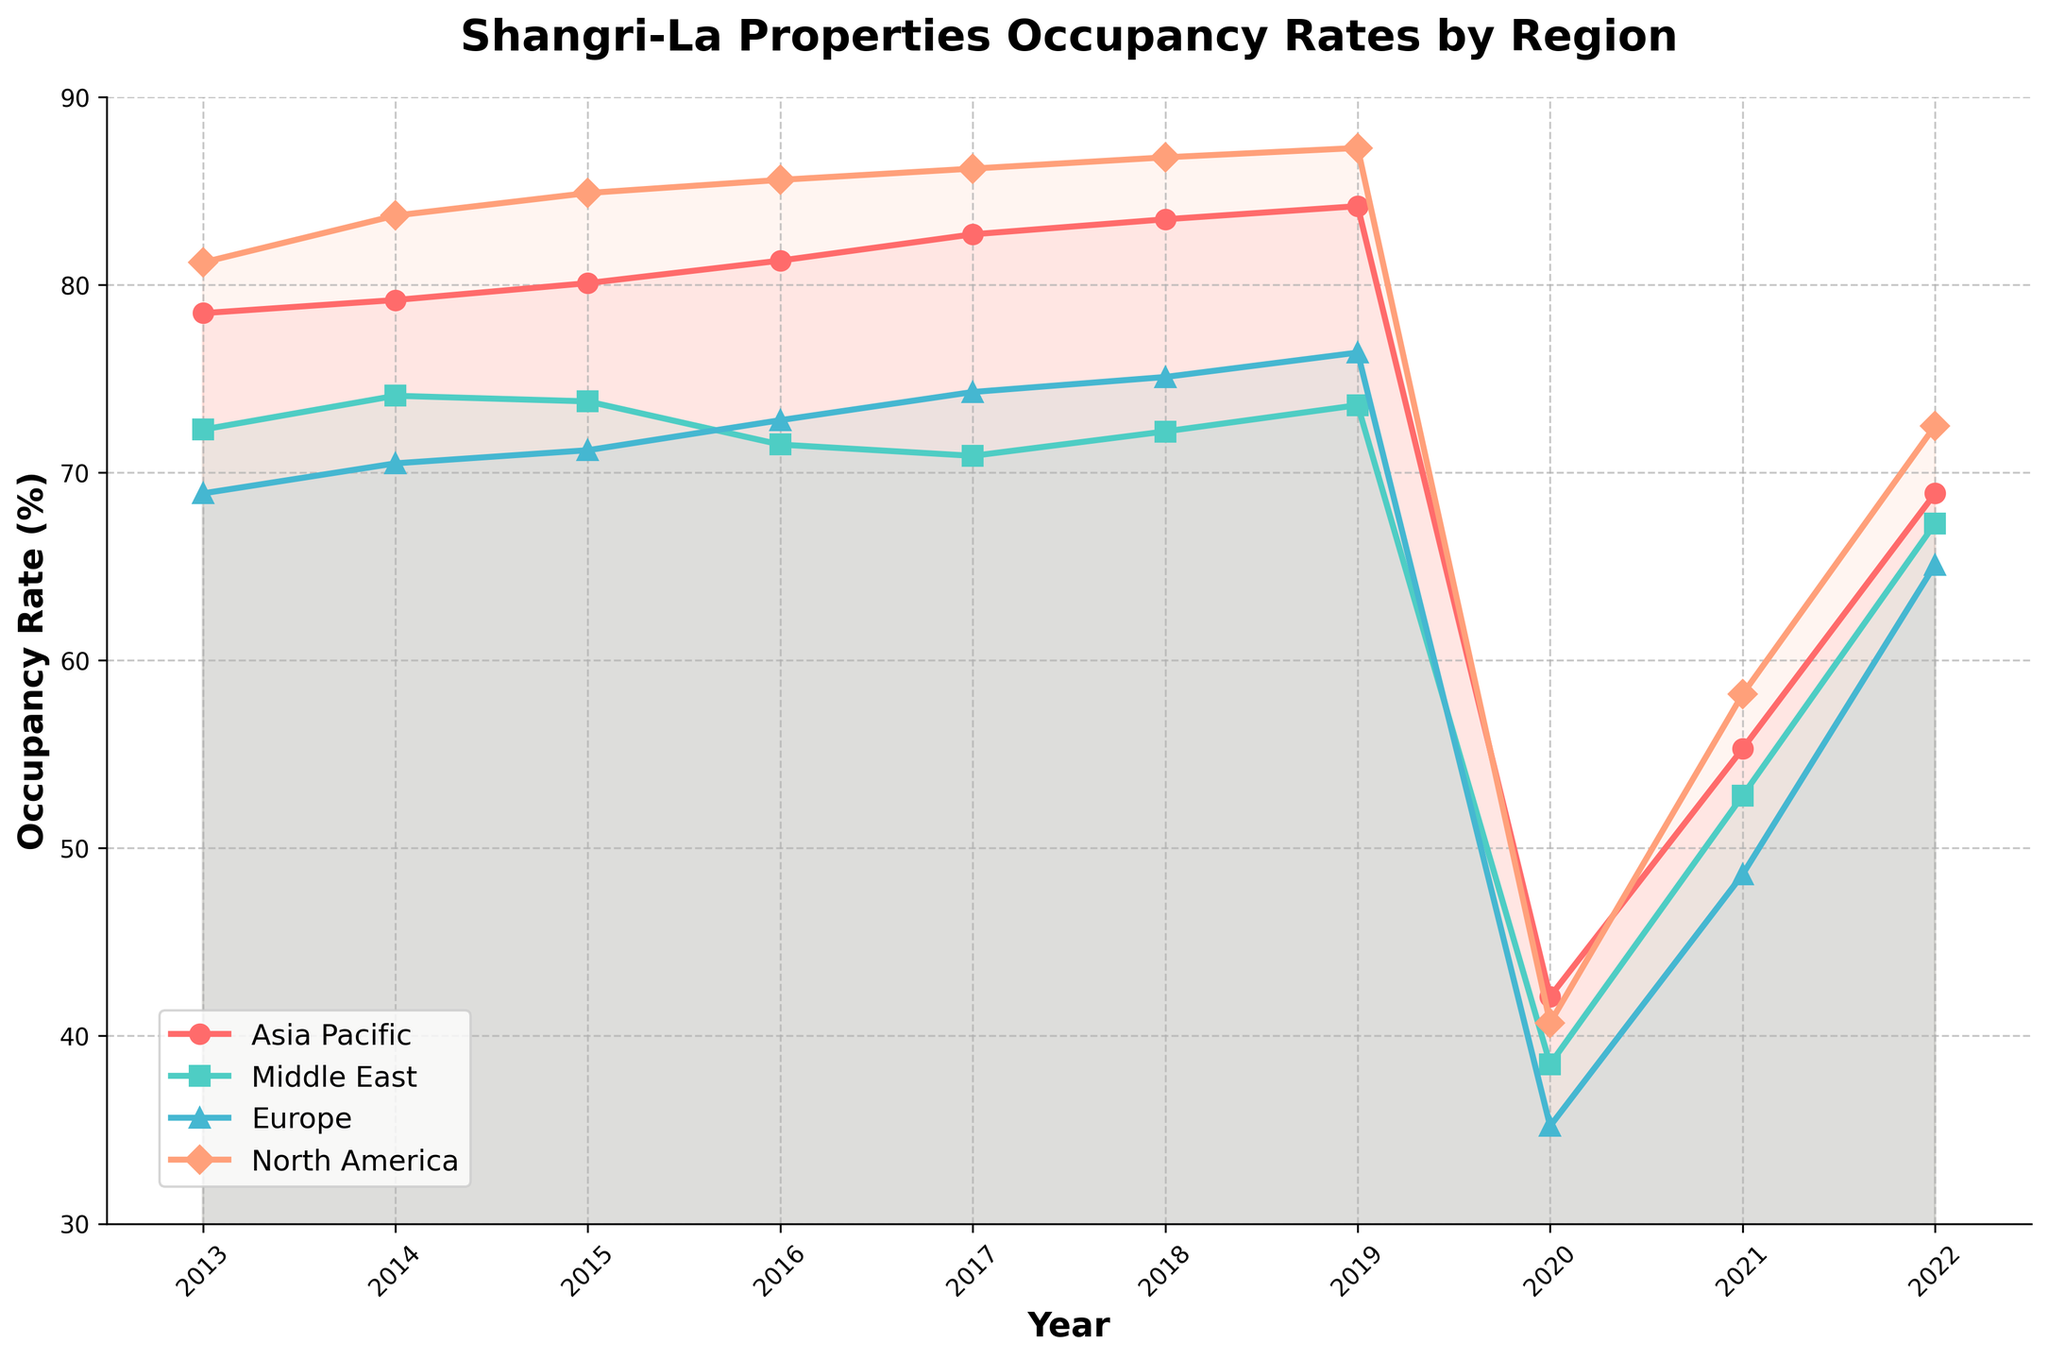What was the overall trend in occupancy rates for the Asia Pacific region from 2013 to 2022? Look at the line for the Asia Pacific region, which shows an increasing trend from 2013 to 2019, a sharp drop in 2020, followed by a recovery trend until 2022.
Answer: Increasing, then sharp decrease and recovery Which region experienced the highest occupancy rate in 2019? Identify the highest point in 2019 among all regions by looking at the markers. North America's line is at the highest point in 2019.
Answer: North America How did the occupancy rate in Europe change from 2015 to 2021? Trace the line for Europe from 2015 to 2021, noticing that it slightly increases, drops significantly in 2020, then recovers moderately in 2021.
Answer: Slight increase, sharp decrease, moderate recovery Which region showed the most significant decline in occupancy rate in 2020? Observe the steepness of the lines in 2020; the Asia Pacific region shows the most significant decline.
Answer: Asia Pacific Calculate the average occupancy rate for the Middle East from 2013 to 2022. Sum the occupancy rates for the Middle East across all years and divide by the number of years (10). Total: (72.3 + 74.1 + 73.8 + 71.5 + 70.9 + 72.2 + 73.6 + 38.5 + 52.8 + 67.3) = 667.1. Average = 667.1 / 10 = 66.7.
Answer: 66.7 Which year's occupancy rate in North America was closest to the occupancy rate in the Asia Pacific in 2014? Compare 2014 Asia Pacific (79.2) with North American values across the years. The closest match is 2013 (81.2), differing only by 2.
Answer: 2013 Compare the occupancy rates in 2022 between Europe and the Asia Pacific. Which region had a higher rate? Check the 2022 values for Europe (65.1) and the Asia Pacific (68.9). Asia Pacific had a higher rate.
Answer: Asia Pacific By how much did the occupancy rate for the Middle East increase from 2020 to 2022? Subtract the 2020 value from the 2022 value for the Middle East: 67.3 - 38.5 = 28.8.
Answer: 28.8 Which region had a more consistent occupancy rate from 2013 to 2019, Europe or the Middle East? By observing the fluctuations in the lines, the Europe line shows more fluctuations compared to the relatively steady Middle East line.
Answer: Middle East 